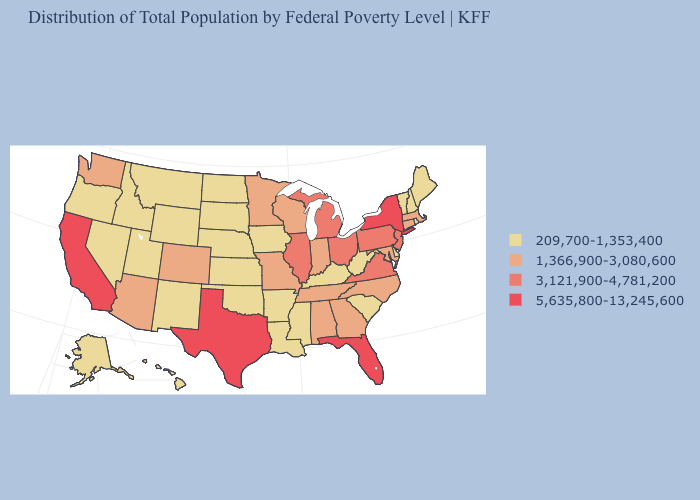What is the highest value in the MidWest ?
Concise answer only. 3,121,900-4,781,200. Which states hav the highest value in the MidWest?
Quick response, please. Illinois, Michigan, Ohio. Name the states that have a value in the range 5,635,800-13,245,600?
Short answer required. California, Florida, New York, Texas. Among the states that border Pennsylvania , which have the highest value?
Write a very short answer. New York. What is the value of Idaho?
Concise answer only. 209,700-1,353,400. How many symbols are there in the legend?
Be succinct. 4. Among the states that border Nebraska , does South Dakota have the lowest value?
Be succinct. Yes. Name the states that have a value in the range 3,121,900-4,781,200?
Write a very short answer. Illinois, Michigan, New Jersey, Ohio, Pennsylvania, Virginia. What is the lowest value in states that border Kentucky?
Write a very short answer. 209,700-1,353,400. Name the states that have a value in the range 3,121,900-4,781,200?
Write a very short answer. Illinois, Michigan, New Jersey, Ohio, Pennsylvania, Virginia. What is the value of Utah?
Answer briefly. 209,700-1,353,400. Does Virginia have a higher value than West Virginia?
Quick response, please. Yes. What is the highest value in the South ?
Give a very brief answer. 5,635,800-13,245,600. Name the states that have a value in the range 209,700-1,353,400?
Quick response, please. Alaska, Arkansas, Delaware, Hawaii, Idaho, Iowa, Kansas, Kentucky, Louisiana, Maine, Mississippi, Montana, Nebraska, Nevada, New Hampshire, New Mexico, North Dakota, Oklahoma, Oregon, Rhode Island, South Carolina, South Dakota, Utah, Vermont, West Virginia, Wyoming. 